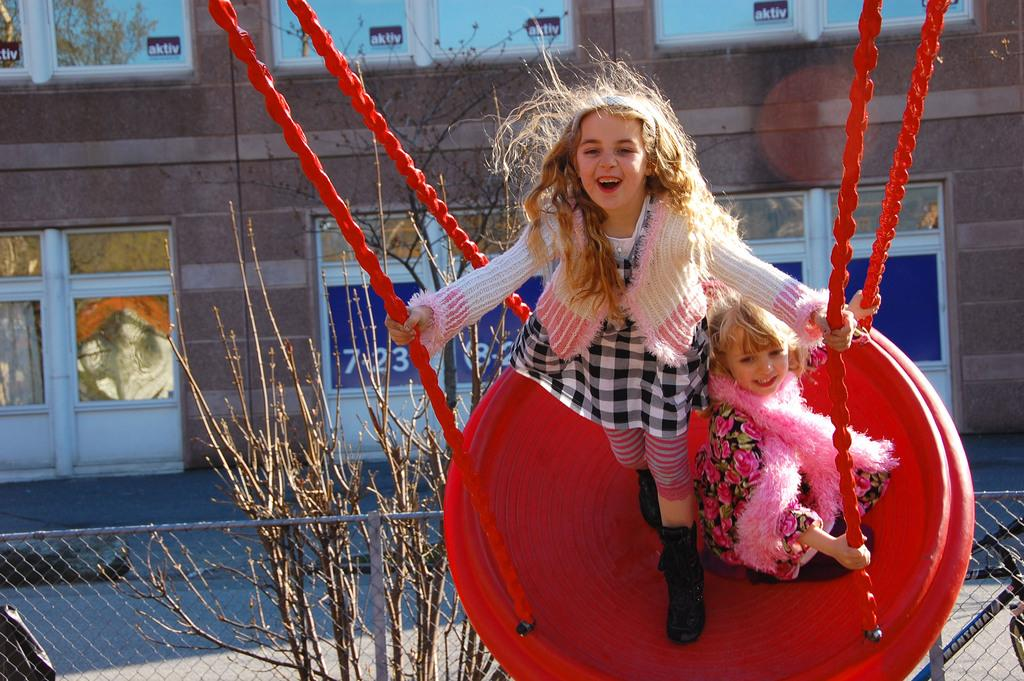How many kids are in the swing in the image? There are two kids in the swing in the image. What is located at the bottom of the image? There is a fence at the bottom of the image. What can be seen in the background of the image? There are plants visible in the background, and there is a wall with doors and windows. What grade are the kids in the swing currently attending? There is no information about the kids' grade in the image. --- Facts: 1. There is a person holding a book in the image. 2. The book has a blue cover. 3. The person is sitting on a chair. 4. There is a table next to the chair. 5. There is a lamp on the table. Absurd Topics: parrot, ocean, dance Conversation: What is the person in the image holding? The person in the image is holding a book. What color is the book's cover? The book has a blue cover. Where is the person sitting in the image? The person is sitting on a chair. What is located next to the chair? There is a table next to the chair. What object is on the table? There is a lamp on the table. Reasoning: Let's think step by step in order to produce the conversation. We start by identifying the main subject in the image, which is the person holding a book. Then, we expand the conversation to include other elements of the image, such as the book's color, the person's location, the table, and the lamp. Each question is designed to elicit a specific detail about the image that is known from the provided facts. Absurd Question/Answer: Can you see a parrot sitting on the person's shoulder in the image? No, there is no parrot present in the image. 